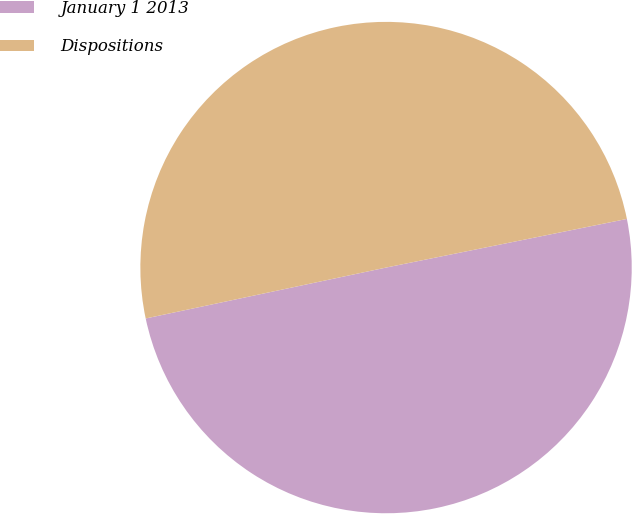<chart> <loc_0><loc_0><loc_500><loc_500><pie_chart><fcel>January 1 2013<fcel>Dispositions<nl><fcel>49.85%<fcel>50.15%<nl></chart> 